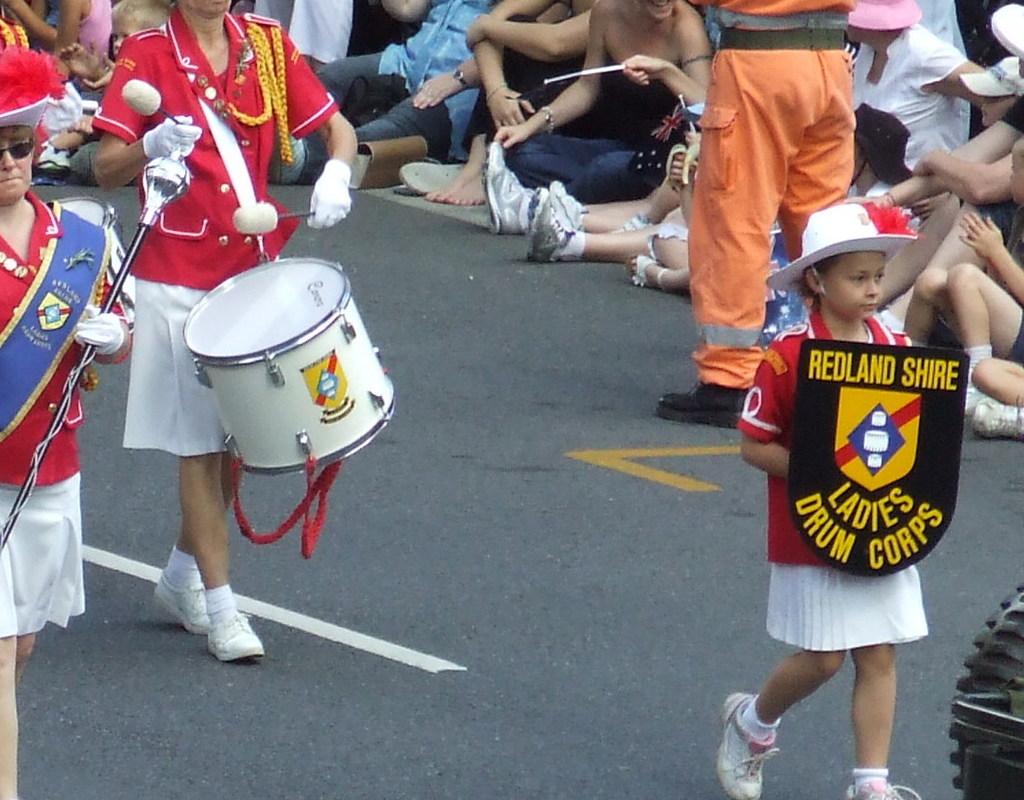What kind of corps is this girl representing?
Ensure brevity in your answer.  Ladies drum. 